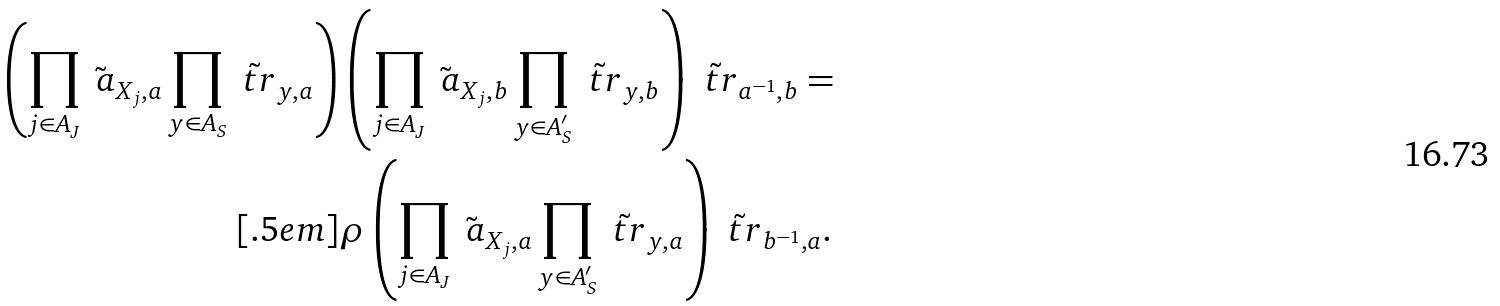<formula> <loc_0><loc_0><loc_500><loc_500>\left ( \prod _ { j \in A _ { J } } \tilde { \ a } _ { X _ { j } , a } \prod _ { y \in A _ { S } } \tilde { \ t r } _ { y , a } \right ) & \left ( \prod _ { j \in A _ { J } } \tilde { \ a } _ { X _ { j } , b } \prod _ { y \in A _ { S } ^ { \prime } } \tilde { \ t r } _ { y , b } \right ) \tilde { \ t r } _ { a ^ { - 1 } , b } = \\ [ . 5 e m ] & \rho \left ( \prod _ { j \in A _ { J } } \tilde { \ a } _ { X _ { j } , a } \prod _ { y \in A _ { S } ^ { \prime } } \tilde { \ t r } _ { y , a } \right ) \tilde { \ t r } _ { b ^ { - 1 } , a } .</formula> 